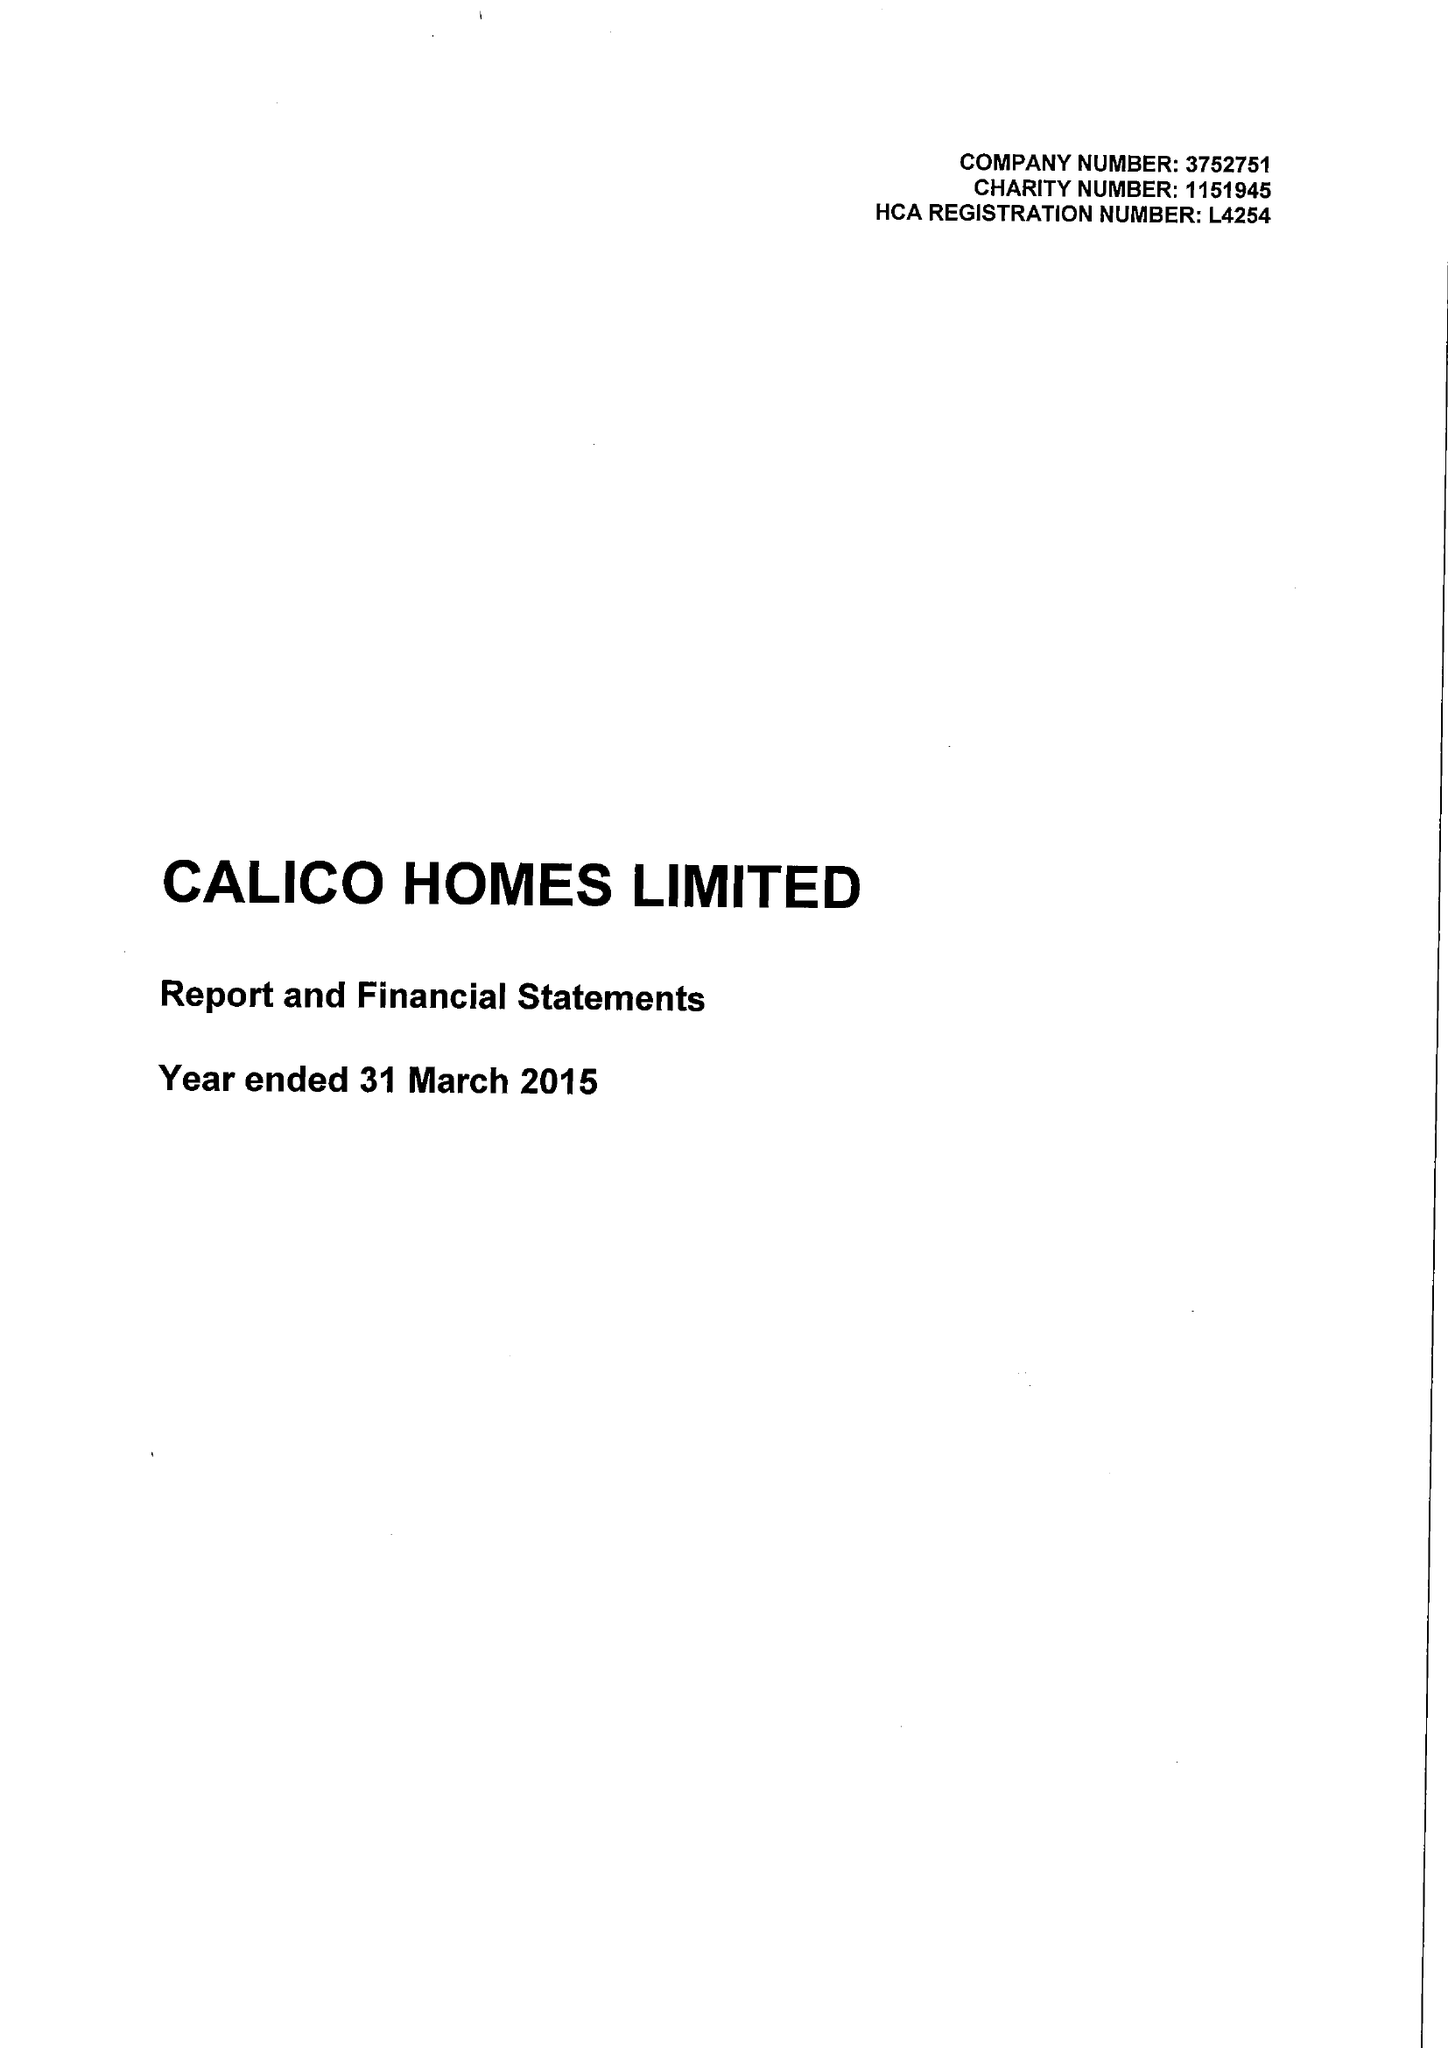What is the value for the address__postcode?
Answer the question using a single word or phrase. BB11 2ED 